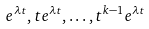Convert formula to latex. <formula><loc_0><loc_0><loc_500><loc_500>e ^ { \lambda t } , t e ^ { \lambda t } , \dots , t ^ { k - 1 } e ^ { \lambda t }</formula> 